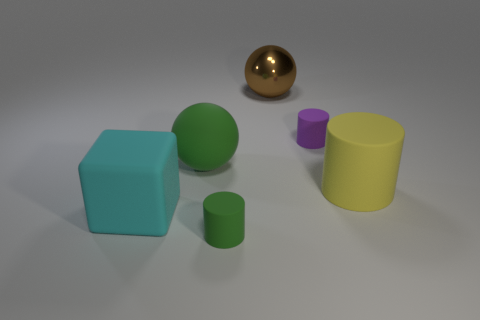Add 1 big purple things. How many objects exist? 7 Subtract all blocks. How many objects are left? 5 Add 5 large red matte cubes. How many large red matte cubes exist? 5 Subtract 0 blue cylinders. How many objects are left? 6 Subtract all big brown things. Subtract all tiny purple rubber things. How many objects are left? 4 Add 4 tiny rubber objects. How many tiny rubber objects are left? 6 